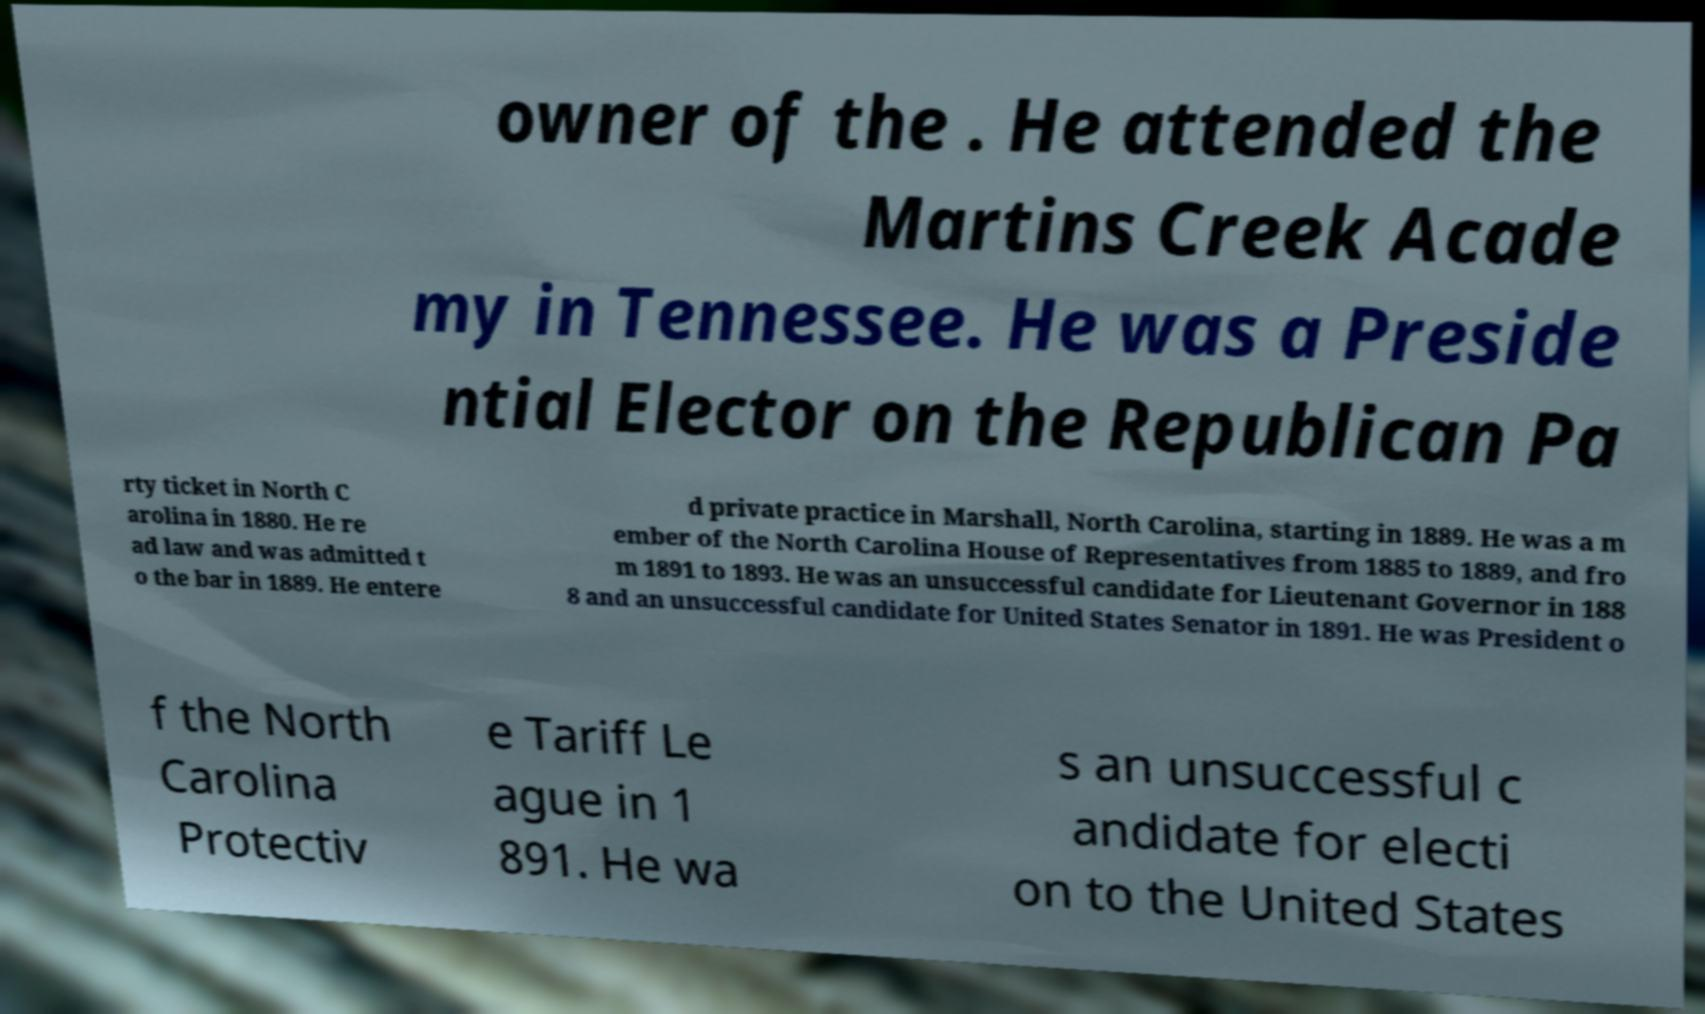For documentation purposes, I need the text within this image transcribed. Could you provide that? owner of the . He attended the Martins Creek Acade my in Tennessee. He was a Preside ntial Elector on the Republican Pa rty ticket in North C arolina in 1880. He re ad law and was admitted t o the bar in 1889. He entere d private practice in Marshall, North Carolina, starting in 1889. He was a m ember of the North Carolina House of Representatives from 1885 to 1889, and fro m 1891 to 1893. He was an unsuccessful candidate for Lieutenant Governor in 188 8 and an unsuccessful candidate for United States Senator in 1891. He was President o f the North Carolina Protectiv e Tariff Le ague in 1 891. He wa s an unsuccessful c andidate for electi on to the United States 